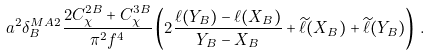Convert formula to latex. <formula><loc_0><loc_0><loc_500><loc_500>a ^ { 2 } \delta _ { B } ^ { M A 2 } \frac { 2 C _ { \chi } ^ { 2 B } + C _ { \chi } ^ { 3 B } } { \pi ^ { 2 } f ^ { 4 } } \left ( 2 \frac { \ell ( Y _ { B } ) - \ell ( X _ { B } ) } { Y _ { B } - X _ { B } } + \widetilde { \ell } ( X _ { B } ) + \widetilde { \ell } ( Y _ { B } ) \right ) \, .</formula> 